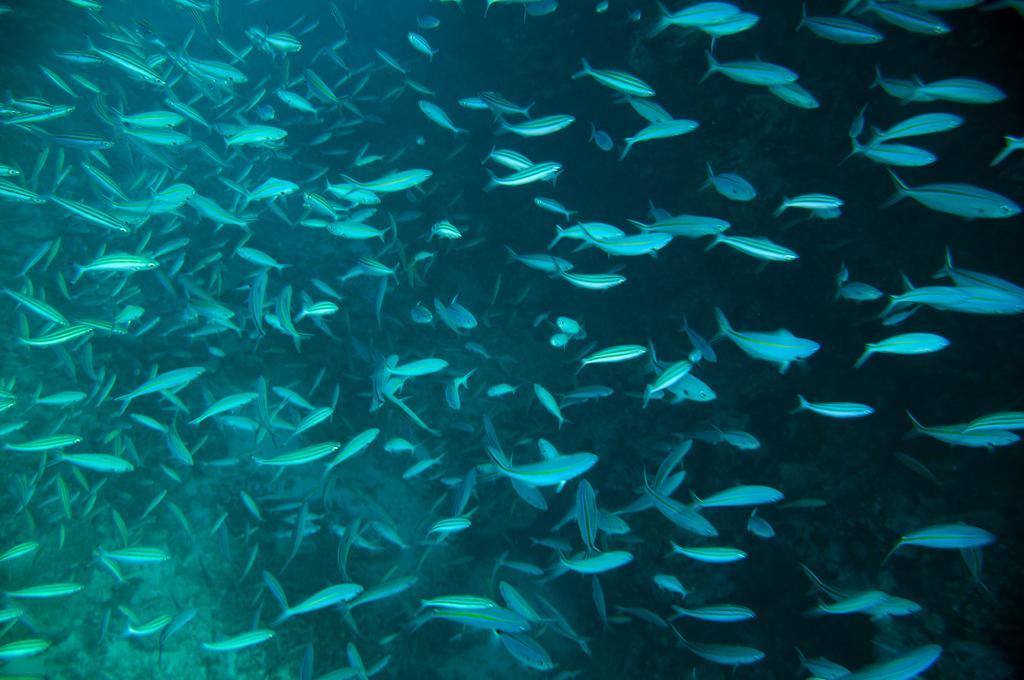How would you summarize this image in a sentence or two? In this picture we can see the fishes in the water. 